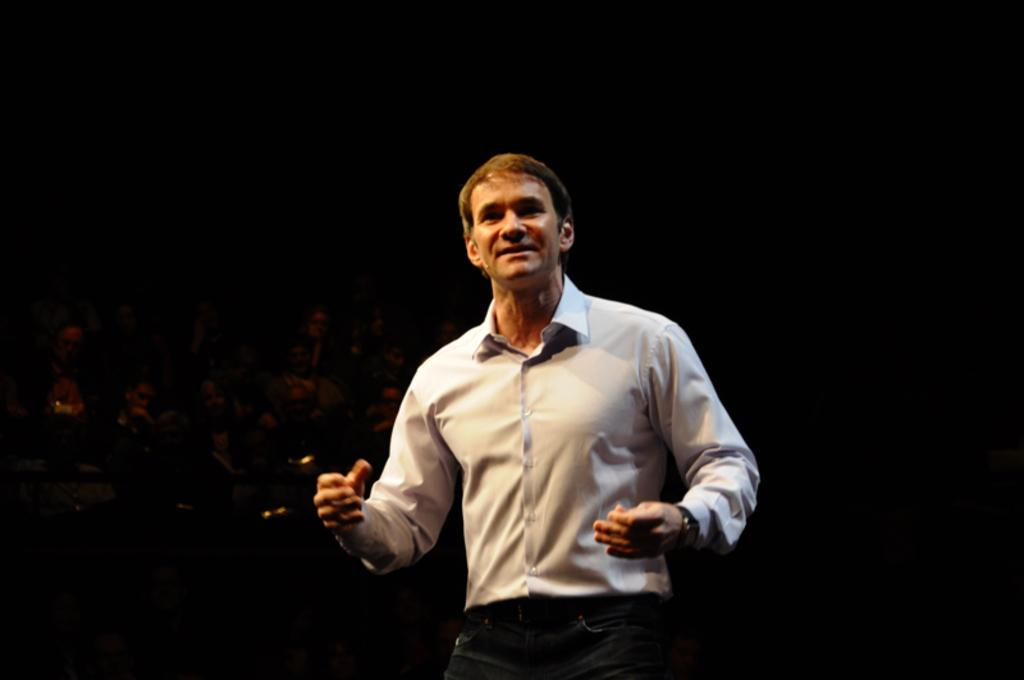Who is the main subject in the image? There is a man in the image. What is the man wearing? The man is wearing a white shirt and black pants. What can be seen in the background of the image? There are many people sitting in the background of the image. How would you describe the lighting in the image? The background of the image is dark. What type of discovery can be seen in the image? There is no discovery present in the image; it features a man wearing a white shirt and black pants, with many people sitting in the background. How many trees are visible in the image? There are no trees visible in the image. 